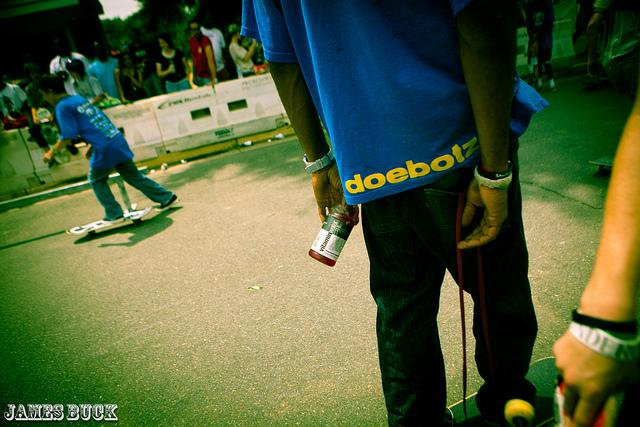What flavoured beverage is in the bottle? vitamin water 